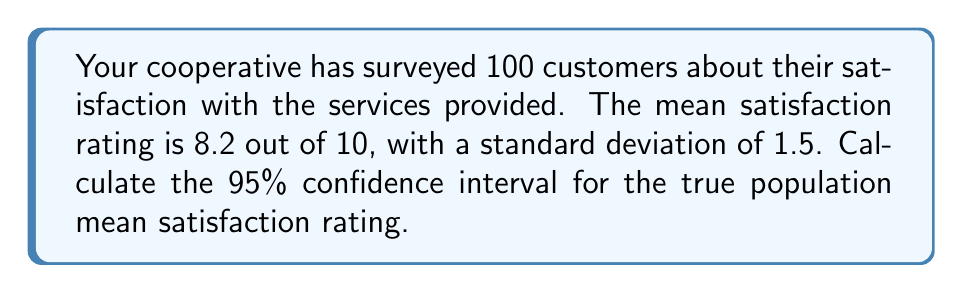Help me with this question. To calculate the 95% confidence interval for the population mean, we'll use the formula:

$$ \text{CI} = \bar{x} \pm t_{\alpha/2} \cdot \frac{s}{\sqrt{n}} $$

Where:
- $\bar{x}$ is the sample mean (8.2)
- $s$ is the sample standard deviation (1.5)
- $n$ is the sample size (100)
- $t_{\alpha/2}$ is the t-value for a 95% confidence level with 99 degrees of freedom

Steps:
1. Find $t_{\alpha/2}$:
   With 99 degrees of freedom and 95% confidence, $t_{\alpha/2} \approx 1.984$

2. Calculate the standard error:
   $$ SE = \frac{s}{\sqrt{n}} = \frac{1.5}{\sqrt{100}} = 0.15 $$

3. Calculate the margin of error:
   $$ ME = t_{\alpha/2} \cdot SE = 1.984 \cdot 0.15 \approx 0.2976 $$

4. Calculate the confidence interval:
   $$ CI = 8.2 \pm 0.2976 $$
   $$ CI = (7.9024, 8.4976) $$
Answer: (7.90, 8.50) 